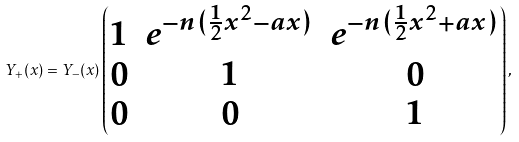<formula> <loc_0><loc_0><loc_500><loc_500>Y _ { + } ( x ) = Y _ { - } ( x ) \begin{pmatrix} 1 & e ^ { - n ( \frac { 1 } { 2 } x ^ { 2 } - a x ) } & e ^ { - n ( \frac { 1 } { 2 } x ^ { 2 } + a x ) } \\ 0 & 1 & 0 \\ 0 & 0 & 1 \end{pmatrix} ,</formula> 